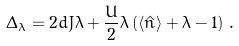<formula> <loc_0><loc_0><loc_500><loc_500>\Delta _ { \lambda } = 2 d J \lambda + \frac { U } { 2 } \lambda \left ( \langle \hat { n } \rangle + \lambda - 1 \right ) \, .</formula> 